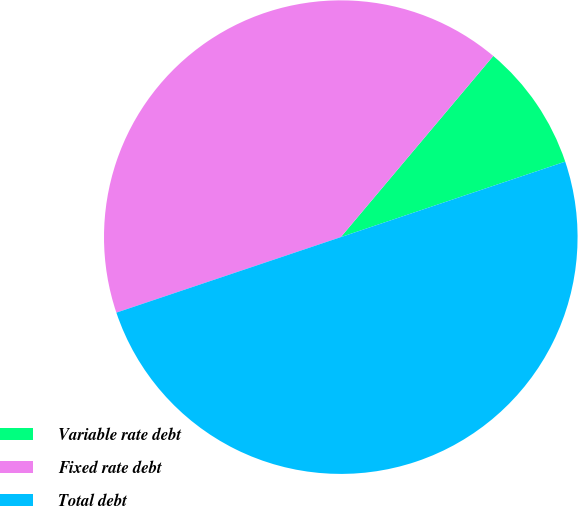Convert chart. <chart><loc_0><loc_0><loc_500><loc_500><pie_chart><fcel>Variable rate debt<fcel>Fixed rate debt<fcel>Total debt<nl><fcel>8.7%<fcel>41.3%<fcel>50.0%<nl></chart> 